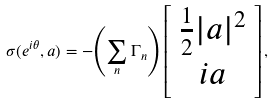<formula> <loc_0><loc_0><loc_500><loc_500>\sigma ( e ^ { i \theta } , a ) = - { \left ( \sum _ { n } \Gamma _ { n } \right ) } \left [ \begin{array} { c } \frac { 1 } { 2 } | a | ^ { 2 } \\ i a \end{array} \right ] ,</formula> 